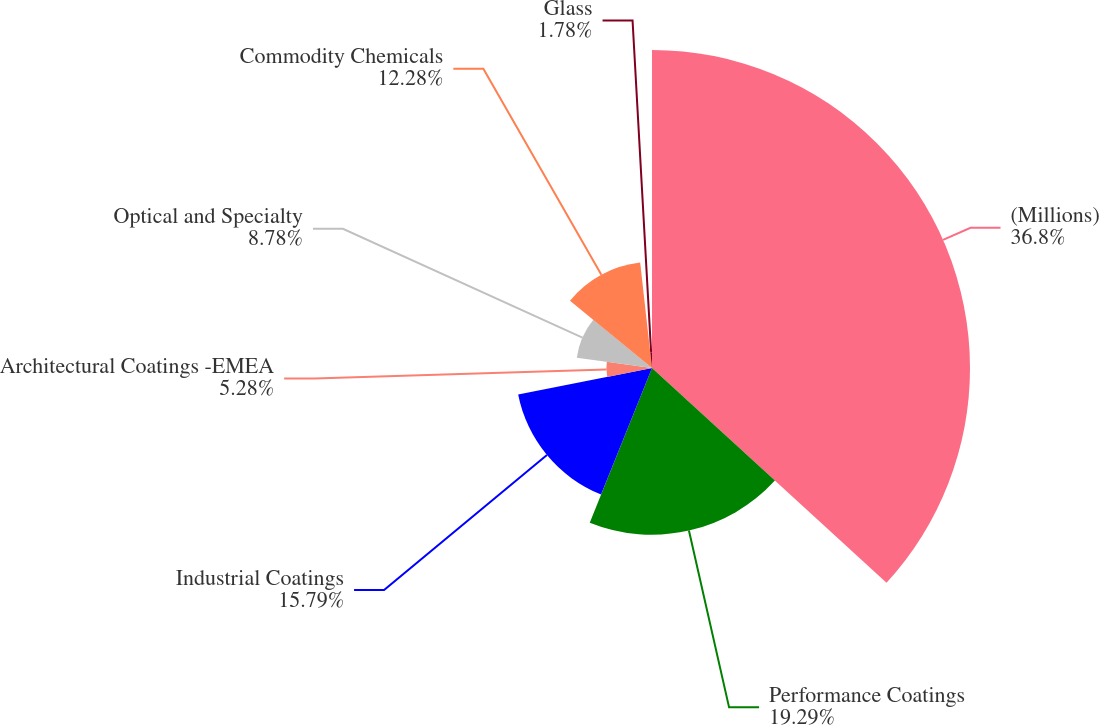<chart> <loc_0><loc_0><loc_500><loc_500><pie_chart><fcel>(Millions)<fcel>Performance Coatings<fcel>Industrial Coatings<fcel>Architectural Coatings -EMEA<fcel>Optical and Specialty<fcel>Commodity Chemicals<fcel>Glass<nl><fcel>36.8%<fcel>19.29%<fcel>15.79%<fcel>5.28%<fcel>8.78%<fcel>12.28%<fcel>1.78%<nl></chart> 